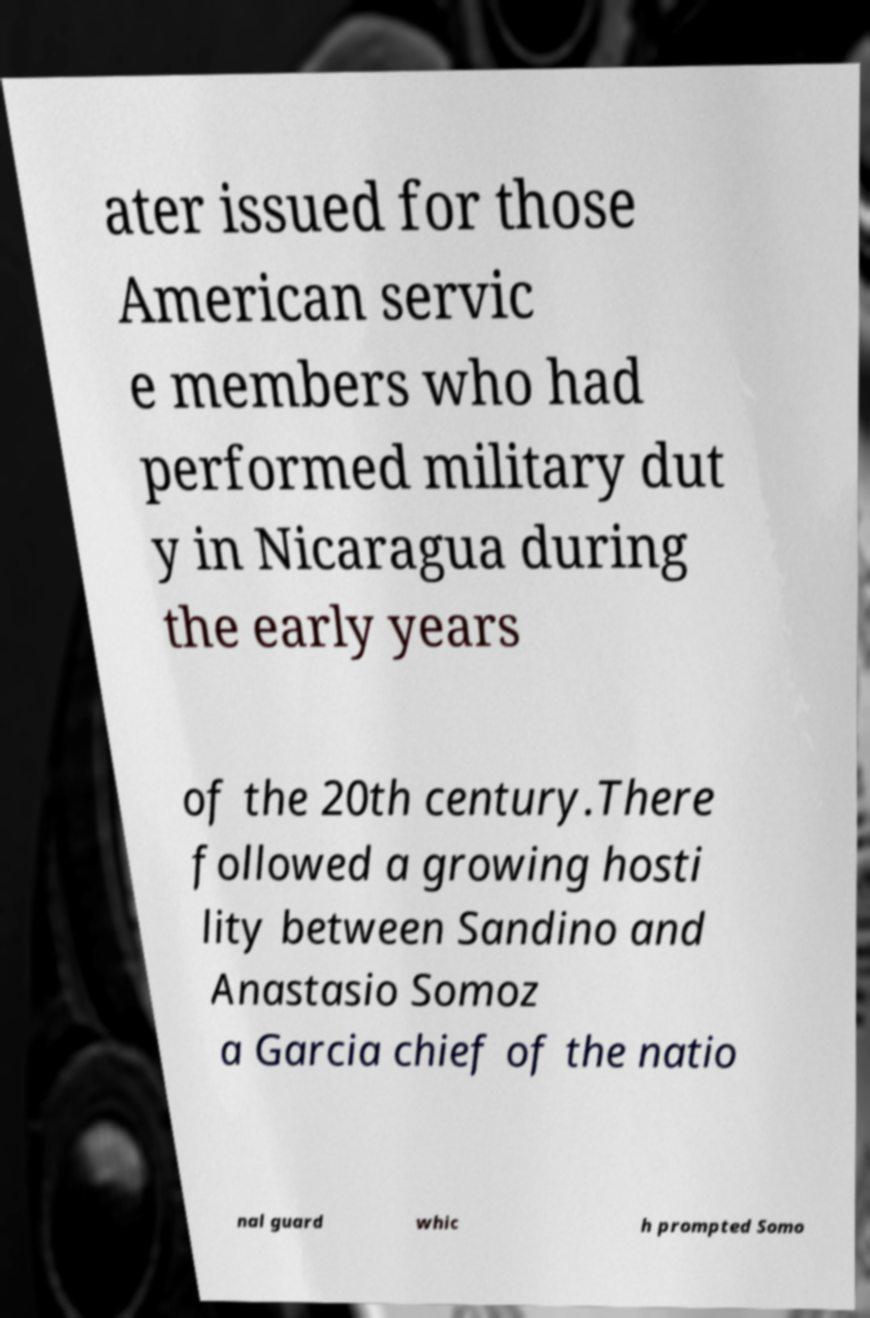There's text embedded in this image that I need extracted. Can you transcribe it verbatim? ater issued for those American servic e members who had performed military dut y in Nicaragua during the early years of the 20th century.There followed a growing hosti lity between Sandino and Anastasio Somoz a Garcia chief of the natio nal guard whic h prompted Somo 